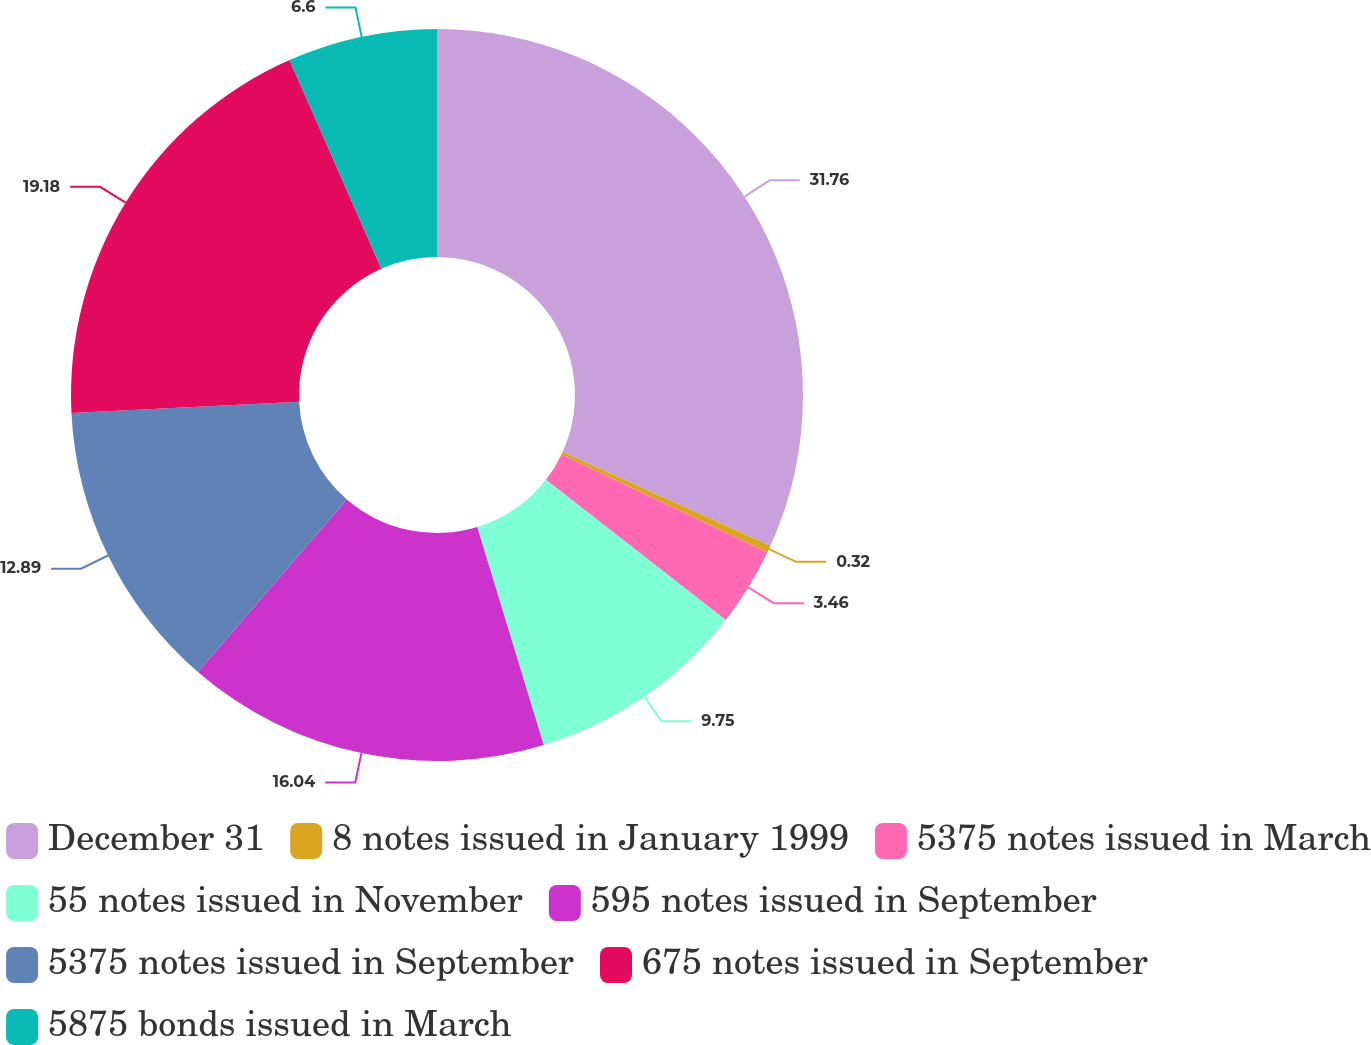Convert chart. <chart><loc_0><loc_0><loc_500><loc_500><pie_chart><fcel>December 31<fcel>8 notes issued in January 1999<fcel>5375 notes issued in March<fcel>55 notes issued in November<fcel>595 notes issued in September<fcel>5375 notes issued in September<fcel>675 notes issued in September<fcel>5875 bonds issued in March<nl><fcel>31.76%<fcel>0.32%<fcel>3.46%<fcel>9.75%<fcel>16.04%<fcel>12.89%<fcel>19.18%<fcel>6.6%<nl></chart> 